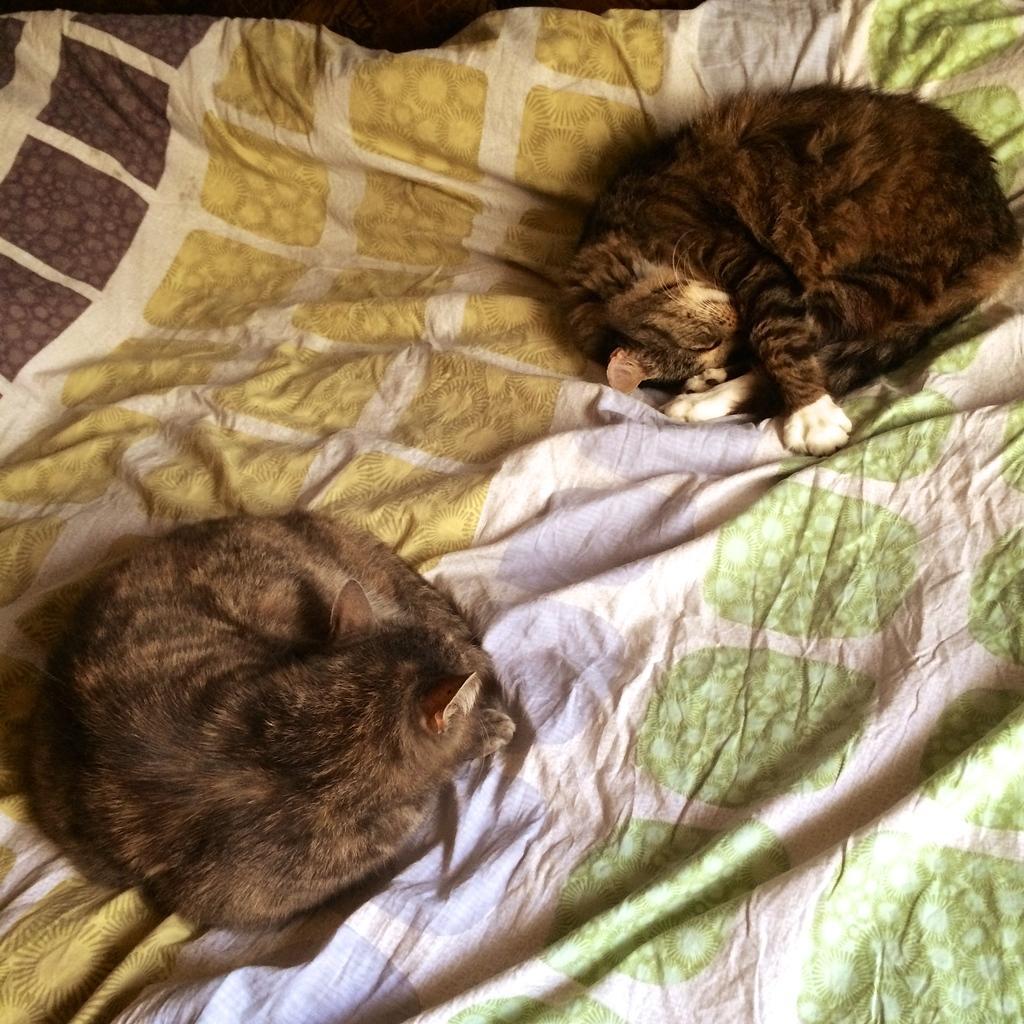Could you give a brief overview of what you see in this image? In this image I can see two cats on the bed. They are in brown,black and white color. The blanket is in different color. 